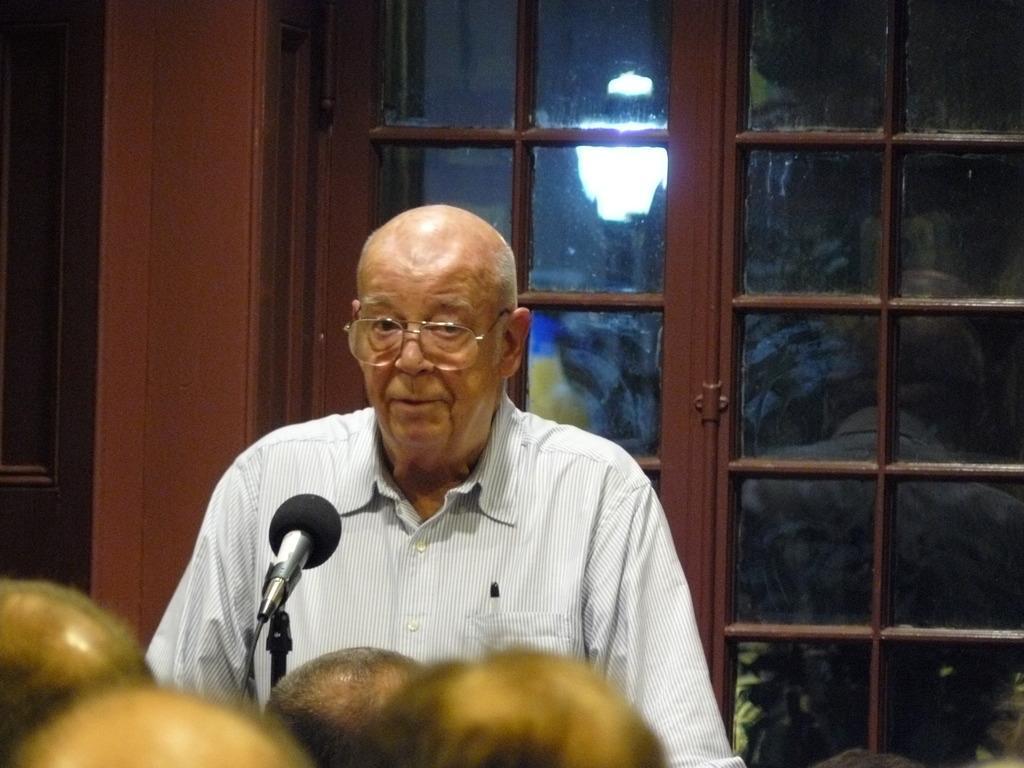In one or two sentences, can you explain what this image depicts? In the image there is a man and there is a mic in front of him, there are few people in front of the man and behind the man there are windows. 